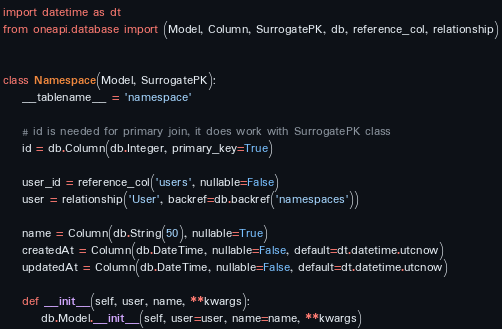Convert code to text. <code><loc_0><loc_0><loc_500><loc_500><_Python_>import datetime as dt
from oneapi.database import (Model, Column, SurrogatePK, db, reference_col, relationship)


class Namespace(Model, SurrogatePK):
    __tablename__ = 'namespace'

    # id is needed for primary join, it does work with SurrogatePK class
    id = db.Column(db.Integer, primary_key=True)

    user_id = reference_col('users', nullable=False)
    user = relationship('User', backref=db.backref('namespaces'))

    name = Column(db.String(50), nullable=True)
    createdAt = Column(db.DateTime, nullable=False, default=dt.datetime.utcnow)
    updatedAt = Column(db.DateTime, nullable=False, default=dt.datetime.utcnow)

    def __init__(self, user, name, **kwargs):
        db.Model.__init__(self, user=user, name=name, **kwargs)
</code> 